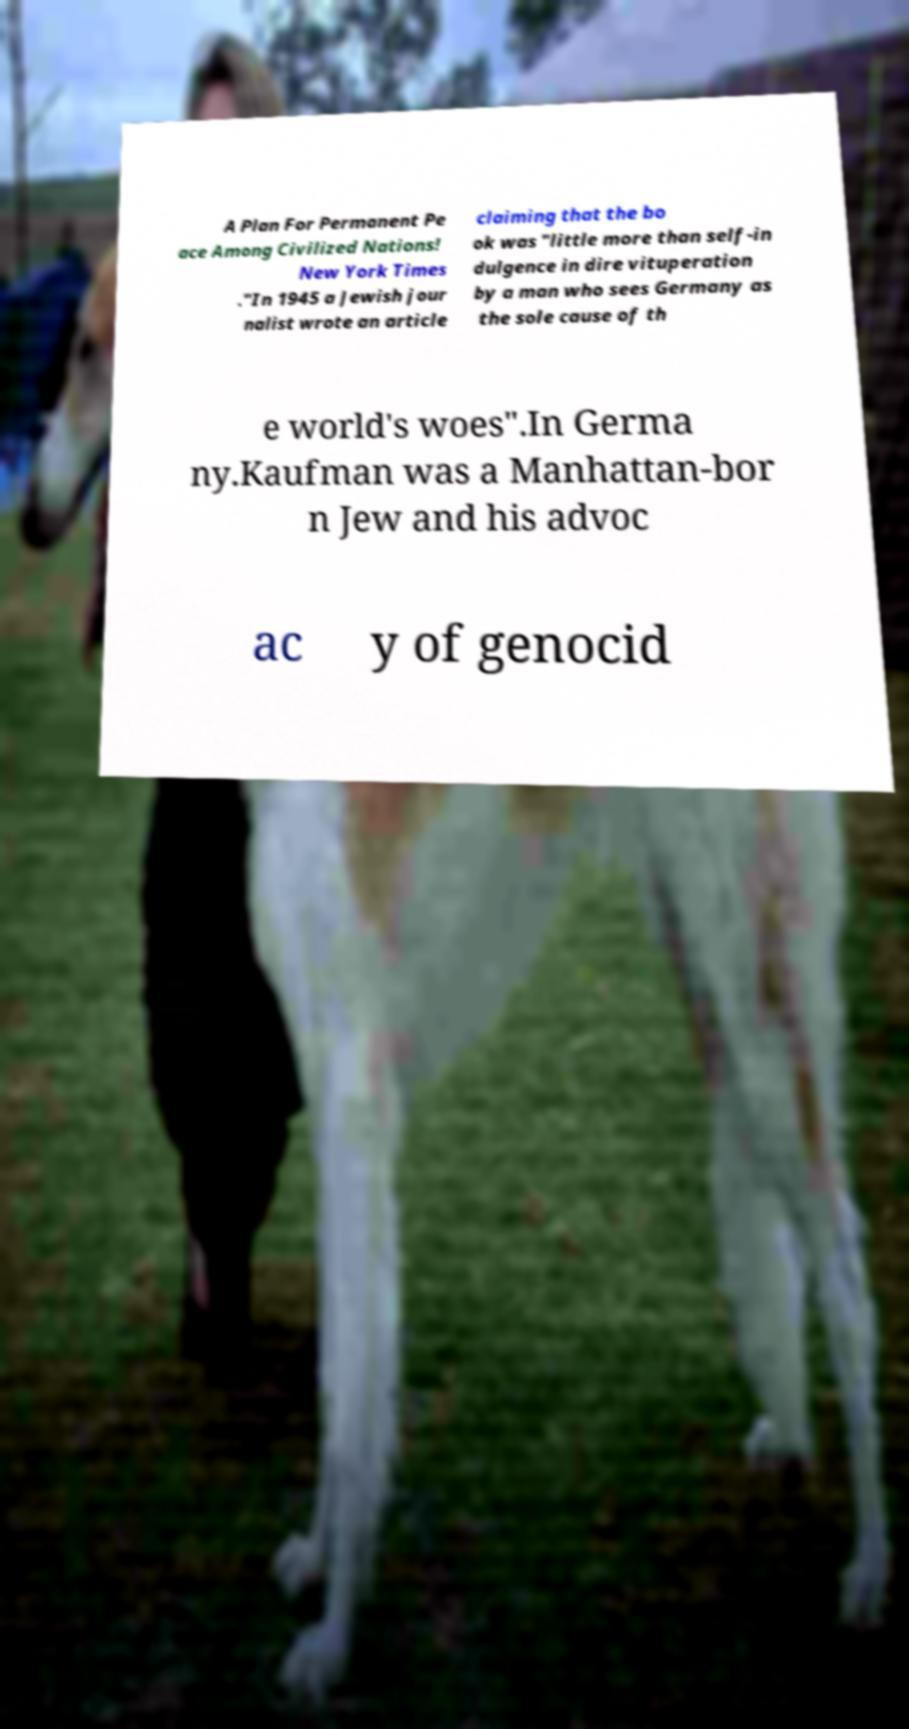There's text embedded in this image that I need extracted. Can you transcribe it verbatim? A Plan For Permanent Pe ace Among Civilized Nations! New York Times ."In 1945 a Jewish jour nalist wrote an article claiming that the bo ok was "little more than self-in dulgence in dire vituperation by a man who sees Germany as the sole cause of th e world's woes".In Germa ny.Kaufman was a Manhattan-bor n Jew and his advoc ac y of genocid 